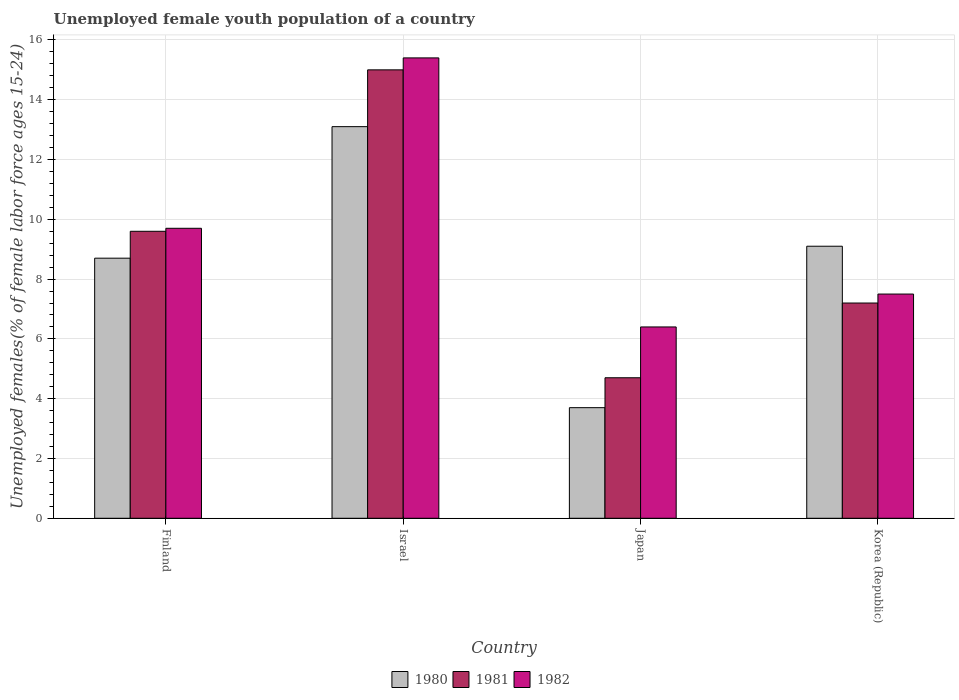How many different coloured bars are there?
Offer a very short reply. 3. How many groups of bars are there?
Offer a very short reply. 4. How many bars are there on the 2nd tick from the left?
Ensure brevity in your answer.  3. In how many cases, is the number of bars for a given country not equal to the number of legend labels?
Provide a short and direct response. 0. What is the percentage of unemployed female youth population in 1981 in Finland?
Ensure brevity in your answer.  9.6. Across all countries, what is the maximum percentage of unemployed female youth population in 1980?
Offer a terse response. 13.1. Across all countries, what is the minimum percentage of unemployed female youth population in 1981?
Ensure brevity in your answer.  4.7. In which country was the percentage of unemployed female youth population in 1980 maximum?
Your answer should be very brief. Israel. In which country was the percentage of unemployed female youth population in 1982 minimum?
Make the answer very short. Japan. What is the total percentage of unemployed female youth population in 1982 in the graph?
Make the answer very short. 39. What is the difference between the percentage of unemployed female youth population in 1980 in Israel and that in Korea (Republic)?
Give a very brief answer. 4. What is the difference between the percentage of unemployed female youth population in 1980 in Finland and the percentage of unemployed female youth population in 1982 in Japan?
Ensure brevity in your answer.  2.3. What is the average percentage of unemployed female youth population in 1982 per country?
Your answer should be very brief. 9.75. What is the difference between the percentage of unemployed female youth population of/in 1981 and percentage of unemployed female youth population of/in 1982 in Israel?
Make the answer very short. -0.4. In how many countries, is the percentage of unemployed female youth population in 1981 greater than 2 %?
Ensure brevity in your answer.  4. What is the ratio of the percentage of unemployed female youth population in 1982 in Japan to that in Korea (Republic)?
Your answer should be compact. 0.85. Is the percentage of unemployed female youth population in 1981 in Japan less than that in Korea (Republic)?
Keep it short and to the point. Yes. What is the difference between the highest and the second highest percentage of unemployed female youth population in 1980?
Give a very brief answer. -0.4. What is the difference between the highest and the lowest percentage of unemployed female youth population in 1980?
Your answer should be very brief. 9.4. Is the sum of the percentage of unemployed female youth population in 1981 in Finland and Korea (Republic) greater than the maximum percentage of unemployed female youth population in 1980 across all countries?
Offer a very short reply. Yes. What does the 3rd bar from the left in Finland represents?
Offer a terse response. 1982. How many bars are there?
Provide a short and direct response. 12. How many countries are there in the graph?
Your answer should be very brief. 4. Are the values on the major ticks of Y-axis written in scientific E-notation?
Your response must be concise. No. Does the graph contain any zero values?
Ensure brevity in your answer.  No. How are the legend labels stacked?
Keep it short and to the point. Horizontal. What is the title of the graph?
Provide a short and direct response. Unemployed female youth population of a country. What is the label or title of the Y-axis?
Provide a short and direct response. Unemployed females(% of female labor force ages 15-24). What is the Unemployed females(% of female labor force ages 15-24) in 1980 in Finland?
Ensure brevity in your answer.  8.7. What is the Unemployed females(% of female labor force ages 15-24) in 1981 in Finland?
Keep it short and to the point. 9.6. What is the Unemployed females(% of female labor force ages 15-24) in 1982 in Finland?
Your answer should be very brief. 9.7. What is the Unemployed females(% of female labor force ages 15-24) in 1980 in Israel?
Offer a very short reply. 13.1. What is the Unemployed females(% of female labor force ages 15-24) of 1981 in Israel?
Ensure brevity in your answer.  15. What is the Unemployed females(% of female labor force ages 15-24) of 1982 in Israel?
Give a very brief answer. 15.4. What is the Unemployed females(% of female labor force ages 15-24) in 1980 in Japan?
Offer a very short reply. 3.7. What is the Unemployed females(% of female labor force ages 15-24) in 1981 in Japan?
Your answer should be compact. 4.7. What is the Unemployed females(% of female labor force ages 15-24) in 1982 in Japan?
Keep it short and to the point. 6.4. What is the Unemployed females(% of female labor force ages 15-24) in 1980 in Korea (Republic)?
Give a very brief answer. 9.1. What is the Unemployed females(% of female labor force ages 15-24) of 1981 in Korea (Republic)?
Make the answer very short. 7.2. Across all countries, what is the maximum Unemployed females(% of female labor force ages 15-24) of 1980?
Provide a succinct answer. 13.1. Across all countries, what is the maximum Unemployed females(% of female labor force ages 15-24) of 1982?
Your answer should be very brief. 15.4. Across all countries, what is the minimum Unemployed females(% of female labor force ages 15-24) of 1980?
Give a very brief answer. 3.7. Across all countries, what is the minimum Unemployed females(% of female labor force ages 15-24) of 1981?
Make the answer very short. 4.7. Across all countries, what is the minimum Unemployed females(% of female labor force ages 15-24) of 1982?
Provide a succinct answer. 6.4. What is the total Unemployed females(% of female labor force ages 15-24) of 1980 in the graph?
Your answer should be compact. 34.6. What is the total Unemployed females(% of female labor force ages 15-24) in 1981 in the graph?
Provide a succinct answer. 36.5. What is the difference between the Unemployed females(% of female labor force ages 15-24) of 1980 in Finland and that in Israel?
Offer a very short reply. -4.4. What is the difference between the Unemployed females(% of female labor force ages 15-24) in 1981 in Finland and that in Israel?
Keep it short and to the point. -5.4. What is the difference between the Unemployed females(% of female labor force ages 15-24) of 1982 in Finland and that in Israel?
Ensure brevity in your answer.  -5.7. What is the difference between the Unemployed females(% of female labor force ages 15-24) of 1980 in Finland and that in Japan?
Provide a short and direct response. 5. What is the difference between the Unemployed females(% of female labor force ages 15-24) in 1982 in Finland and that in Korea (Republic)?
Make the answer very short. 2.2. What is the difference between the Unemployed females(% of female labor force ages 15-24) in 1982 in Israel and that in Korea (Republic)?
Keep it short and to the point. 7.9. What is the difference between the Unemployed females(% of female labor force ages 15-24) of 1982 in Japan and that in Korea (Republic)?
Ensure brevity in your answer.  -1.1. What is the difference between the Unemployed females(% of female labor force ages 15-24) in 1981 in Finland and the Unemployed females(% of female labor force ages 15-24) in 1982 in Israel?
Offer a very short reply. -5.8. What is the difference between the Unemployed females(% of female labor force ages 15-24) in 1980 in Finland and the Unemployed females(% of female labor force ages 15-24) in 1982 in Japan?
Ensure brevity in your answer.  2.3. What is the difference between the Unemployed females(% of female labor force ages 15-24) in 1981 in Finland and the Unemployed females(% of female labor force ages 15-24) in 1982 in Japan?
Your response must be concise. 3.2. What is the difference between the Unemployed females(% of female labor force ages 15-24) in 1981 in Finland and the Unemployed females(% of female labor force ages 15-24) in 1982 in Korea (Republic)?
Your answer should be compact. 2.1. What is the difference between the Unemployed females(% of female labor force ages 15-24) of 1980 in Israel and the Unemployed females(% of female labor force ages 15-24) of 1981 in Japan?
Make the answer very short. 8.4. What is the difference between the Unemployed females(% of female labor force ages 15-24) in 1980 in Israel and the Unemployed females(% of female labor force ages 15-24) in 1982 in Japan?
Provide a succinct answer. 6.7. What is the difference between the Unemployed females(% of female labor force ages 15-24) of 1981 in Israel and the Unemployed females(% of female labor force ages 15-24) of 1982 in Japan?
Offer a very short reply. 8.6. What is the difference between the Unemployed females(% of female labor force ages 15-24) of 1980 in Israel and the Unemployed females(% of female labor force ages 15-24) of 1982 in Korea (Republic)?
Your response must be concise. 5.6. What is the difference between the Unemployed females(% of female labor force ages 15-24) in 1981 in Israel and the Unemployed females(% of female labor force ages 15-24) in 1982 in Korea (Republic)?
Your response must be concise. 7.5. What is the average Unemployed females(% of female labor force ages 15-24) in 1980 per country?
Provide a short and direct response. 8.65. What is the average Unemployed females(% of female labor force ages 15-24) in 1981 per country?
Offer a terse response. 9.12. What is the average Unemployed females(% of female labor force ages 15-24) of 1982 per country?
Give a very brief answer. 9.75. What is the difference between the Unemployed females(% of female labor force ages 15-24) of 1980 and Unemployed females(% of female labor force ages 15-24) of 1981 in Finland?
Your response must be concise. -0.9. What is the difference between the Unemployed females(% of female labor force ages 15-24) of 1980 and Unemployed females(% of female labor force ages 15-24) of 1982 in Finland?
Your answer should be compact. -1. What is the difference between the Unemployed females(% of female labor force ages 15-24) of 1981 and Unemployed females(% of female labor force ages 15-24) of 1982 in Finland?
Provide a short and direct response. -0.1. What is the difference between the Unemployed females(% of female labor force ages 15-24) in 1980 and Unemployed females(% of female labor force ages 15-24) in 1981 in Israel?
Keep it short and to the point. -1.9. What is the difference between the Unemployed females(% of female labor force ages 15-24) in 1980 and Unemployed females(% of female labor force ages 15-24) in 1982 in Japan?
Ensure brevity in your answer.  -2.7. What is the difference between the Unemployed females(% of female labor force ages 15-24) in 1980 and Unemployed females(% of female labor force ages 15-24) in 1981 in Korea (Republic)?
Provide a short and direct response. 1.9. What is the ratio of the Unemployed females(% of female labor force ages 15-24) in 1980 in Finland to that in Israel?
Give a very brief answer. 0.66. What is the ratio of the Unemployed females(% of female labor force ages 15-24) in 1981 in Finland to that in Israel?
Make the answer very short. 0.64. What is the ratio of the Unemployed females(% of female labor force ages 15-24) of 1982 in Finland to that in Israel?
Your answer should be very brief. 0.63. What is the ratio of the Unemployed females(% of female labor force ages 15-24) in 1980 in Finland to that in Japan?
Make the answer very short. 2.35. What is the ratio of the Unemployed females(% of female labor force ages 15-24) in 1981 in Finland to that in Japan?
Provide a short and direct response. 2.04. What is the ratio of the Unemployed females(% of female labor force ages 15-24) of 1982 in Finland to that in Japan?
Offer a terse response. 1.52. What is the ratio of the Unemployed females(% of female labor force ages 15-24) of 1980 in Finland to that in Korea (Republic)?
Give a very brief answer. 0.96. What is the ratio of the Unemployed females(% of female labor force ages 15-24) of 1982 in Finland to that in Korea (Republic)?
Keep it short and to the point. 1.29. What is the ratio of the Unemployed females(% of female labor force ages 15-24) in 1980 in Israel to that in Japan?
Make the answer very short. 3.54. What is the ratio of the Unemployed females(% of female labor force ages 15-24) in 1981 in Israel to that in Japan?
Provide a succinct answer. 3.19. What is the ratio of the Unemployed females(% of female labor force ages 15-24) of 1982 in Israel to that in Japan?
Offer a very short reply. 2.41. What is the ratio of the Unemployed females(% of female labor force ages 15-24) in 1980 in Israel to that in Korea (Republic)?
Keep it short and to the point. 1.44. What is the ratio of the Unemployed females(% of female labor force ages 15-24) of 1981 in Israel to that in Korea (Republic)?
Provide a succinct answer. 2.08. What is the ratio of the Unemployed females(% of female labor force ages 15-24) of 1982 in Israel to that in Korea (Republic)?
Offer a very short reply. 2.05. What is the ratio of the Unemployed females(% of female labor force ages 15-24) of 1980 in Japan to that in Korea (Republic)?
Your answer should be very brief. 0.41. What is the ratio of the Unemployed females(% of female labor force ages 15-24) of 1981 in Japan to that in Korea (Republic)?
Offer a very short reply. 0.65. What is the ratio of the Unemployed females(% of female labor force ages 15-24) of 1982 in Japan to that in Korea (Republic)?
Provide a succinct answer. 0.85. What is the difference between the highest and the second highest Unemployed females(% of female labor force ages 15-24) of 1981?
Offer a very short reply. 5.4. What is the difference between the highest and the second highest Unemployed females(% of female labor force ages 15-24) of 1982?
Your answer should be compact. 5.7. 